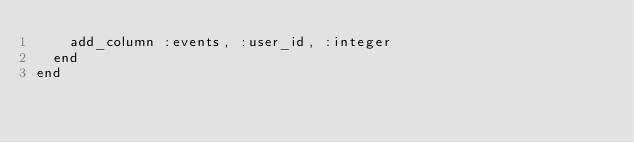<code> <loc_0><loc_0><loc_500><loc_500><_Ruby_>    add_column :events, :user_id, :integer
  end
end
</code> 